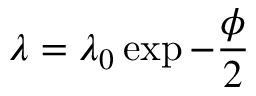Convert formula to latex. <formula><loc_0><loc_0><loc_500><loc_500>\lambda = \lambda _ { 0 } \exp { - \frac { \phi } { 2 } }</formula> 